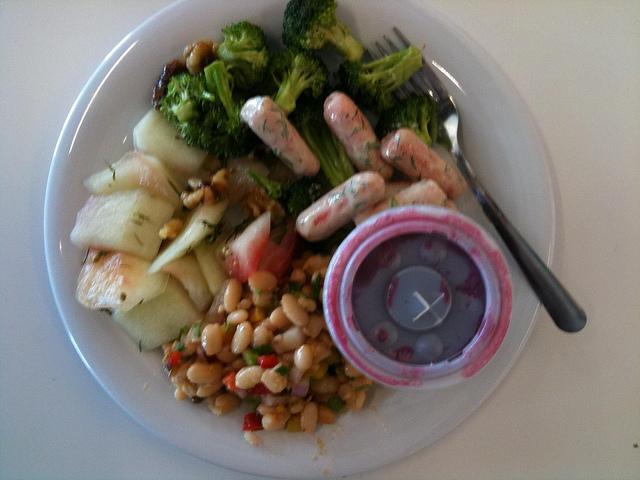Is this meal vegan?
Short answer required. Yes. What are the color of the plates?
Concise answer only. White. What color are the carrots?
Write a very short answer. Orange. What utensils is on the plate?
Short answer required. Fork. What kind of silverware is in the bowl?
Give a very brief answer. Fork. What utensils are shown?
Keep it brief. Fork. What is the green vegetable?
Be succinct. Broccoli. How many bowls of food are there?
Concise answer only. 1. Is this food packed to go?
Short answer required. No. What is in the plastic cup?
Concise answer only. Sauce. What kind of food is shown?
Quick response, please. Vegetarian. What utensil is that?
Keep it brief. Fork. 